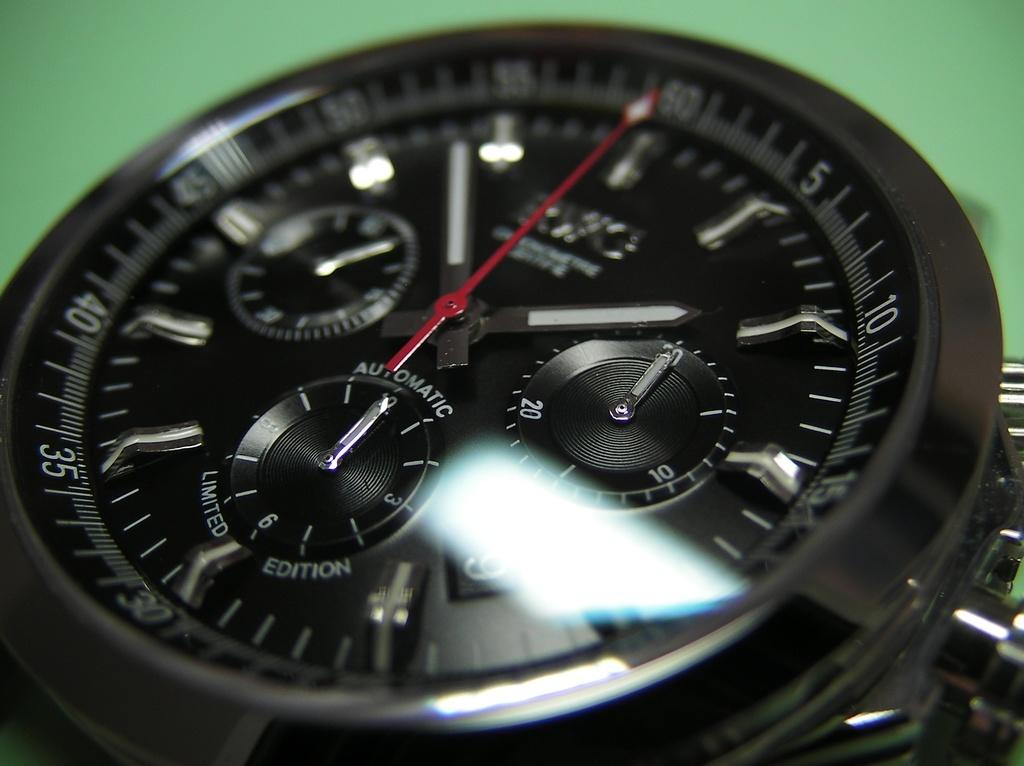What type of watch is visible in the image? There is a black color watch in the image. What color is the background of the image? The background of the image is green. What type of mine is visible in the image? There is no mine present in the image; it features a black color watch against a green background. What type of cap is being worn by the person in the image? There is no person or cap visible in the image; it only shows a black color watch against a green background. 